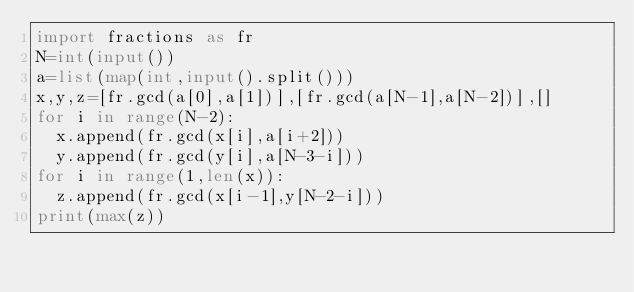<code> <loc_0><loc_0><loc_500><loc_500><_Python_>import fractions as fr
N=int(input())
a=list(map(int,input().split()))
x,y,z=[fr.gcd(a[0],a[1])],[fr.gcd(a[N-1],a[N-2])],[]
for i in range(N-2):
	x.append(fr.gcd(x[i],a[i+2]))
	y.append(fr.gcd(y[i],a[N-3-i]))
for i in range(1,len(x)):
	z.append(fr.gcd(x[i-1],y[N-2-i]))
print(max(z))</code> 